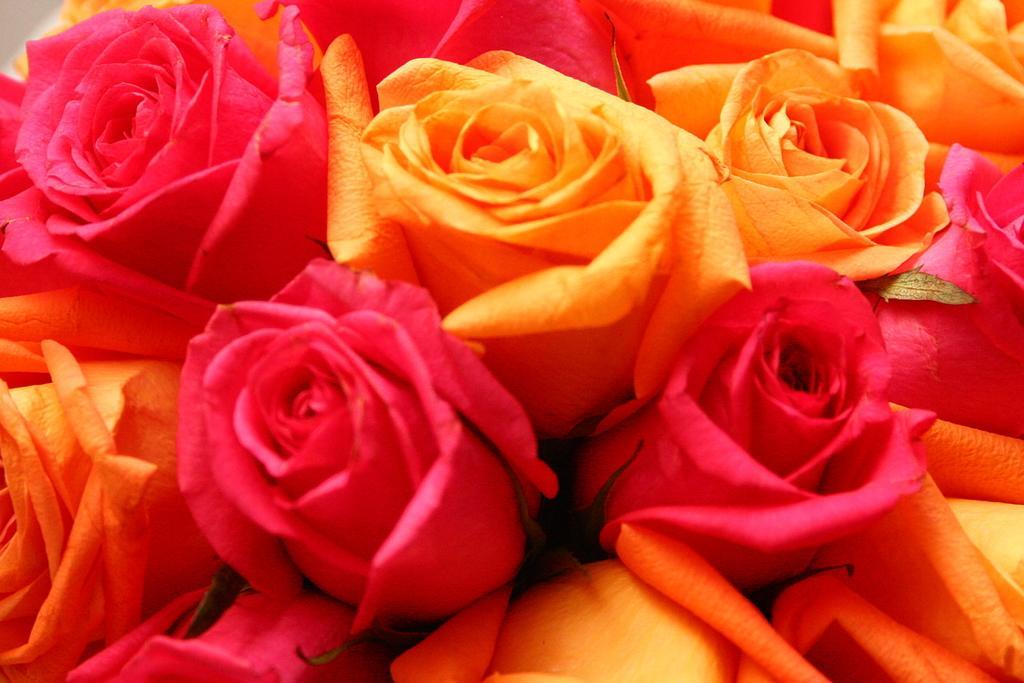Could you give a brief overview of what you see in this image? In this image, we can see roses. 